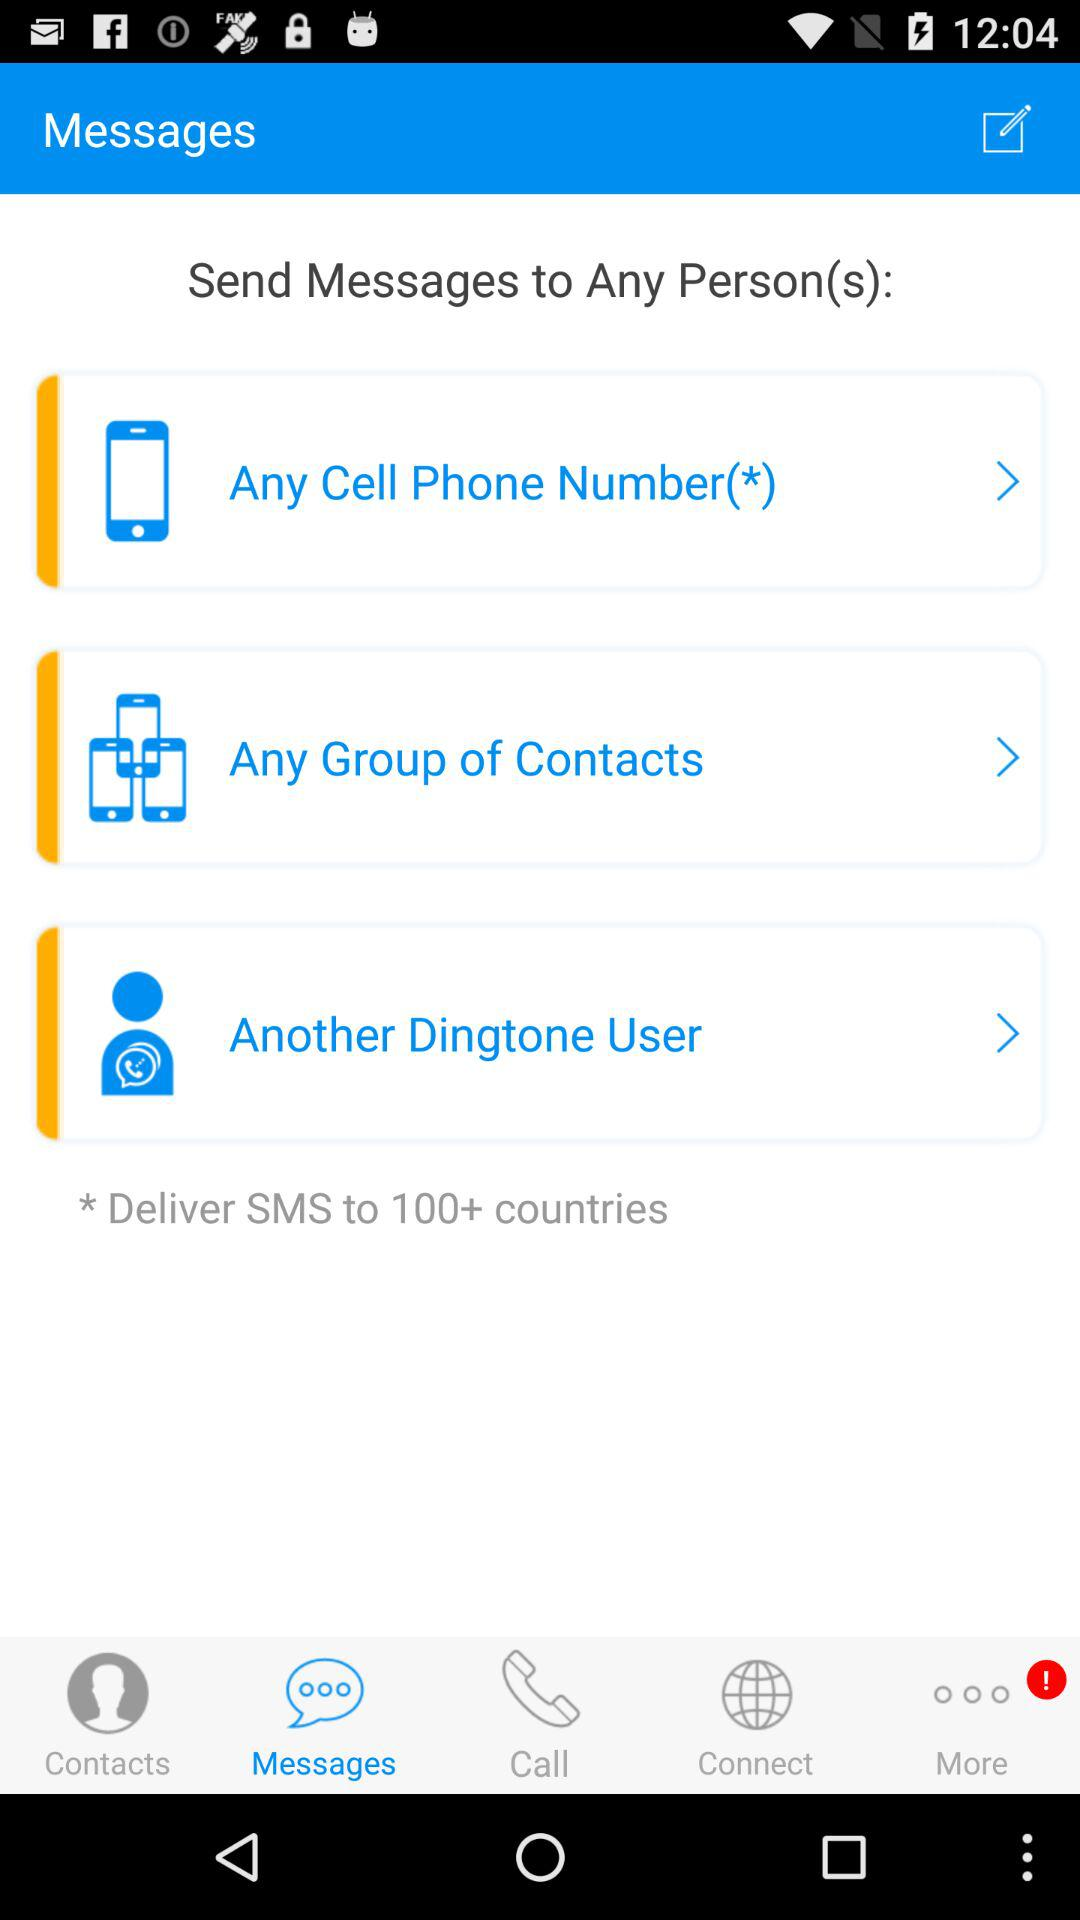SMS is delivered in how many countries? SMS is delivered in 100+ countries. 